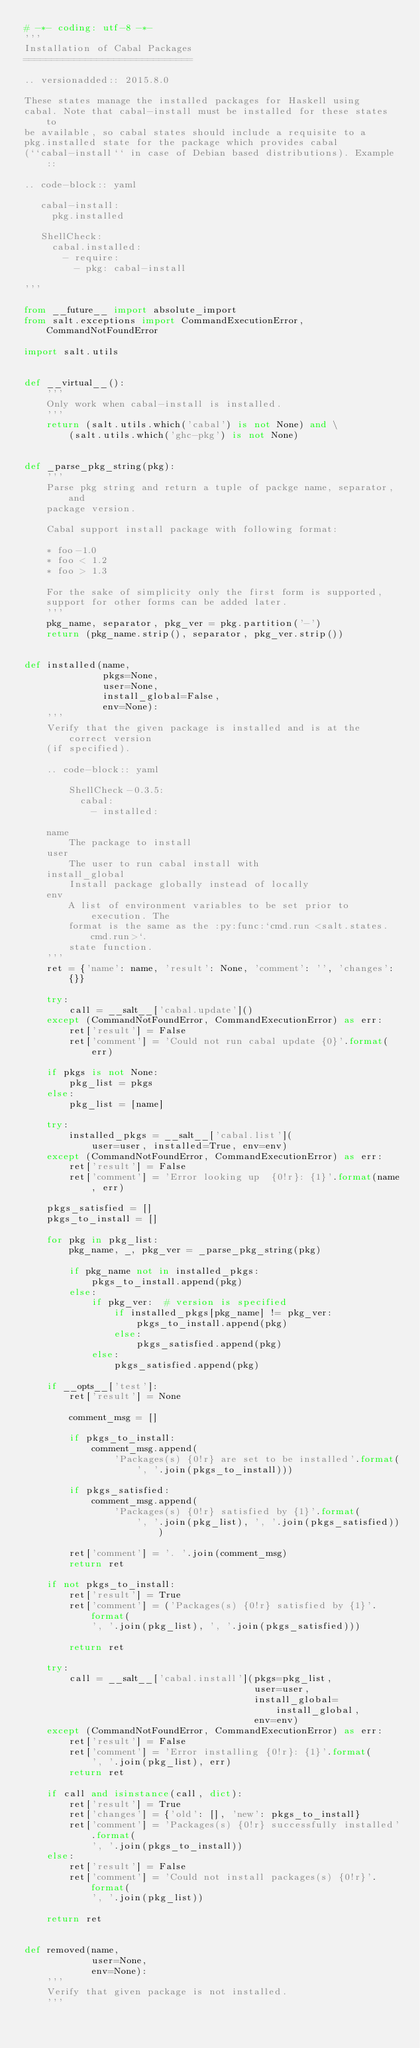Convert code to text. <code><loc_0><loc_0><loc_500><loc_500><_Python_># -*- coding: utf-8 -*-
'''
Installation of Cabal Packages
==============================

.. versionadded:: 2015.8.0

These states manage the installed packages for Haskell using
cabal. Note that cabal-install must be installed for these states to
be available, so cabal states should include a requisite to a
pkg.installed state for the package which provides cabal
(``cabal-install`` in case of Debian based distributions). Example::

.. code-block:: yaml

   cabal-install:
     pkg.installed

   ShellCheck:
     cabal.installed:
       - require:
         - pkg: cabal-install

'''

from __future__ import absolute_import
from salt.exceptions import CommandExecutionError, CommandNotFoundError

import salt.utils


def __virtual__():
    '''
    Only work when cabal-install is installed.
    '''
    return (salt.utils.which('cabal') is not None) and \
        (salt.utils.which('ghc-pkg') is not None)


def _parse_pkg_string(pkg):
    '''
    Parse pkg string and return a tuple of packge name, separator, and
    package version.

    Cabal support install package with following format:

    * foo-1.0
    * foo < 1.2
    * foo > 1.3

    For the sake of simplicity only the first form is supported,
    support for other forms can be added later.
    '''
    pkg_name, separator, pkg_ver = pkg.partition('-')
    return (pkg_name.strip(), separator, pkg_ver.strip())


def installed(name,
              pkgs=None,
              user=None,
              install_global=False,
              env=None):
    '''
    Verify that the given package is installed and is at the correct version
    (if specified).

    .. code-block:: yaml

        ShellCheck-0.3.5:
          cabal:
            - installed:

    name
        The package to install
    user
        The user to run cabal install with
    install_global
        Install package globally instead of locally
    env
        A list of environment variables to be set prior to execution. The
        format is the same as the :py:func:`cmd.run <salt.states.cmd.run>`.
        state function.
    '''
    ret = {'name': name, 'result': None, 'comment': '', 'changes': {}}

    try:
        call = __salt__['cabal.update']()
    except (CommandNotFoundError, CommandExecutionError) as err:
        ret['result'] = False
        ret['comment'] = 'Could not run cabal update {0}'.format(err)

    if pkgs is not None:
        pkg_list = pkgs
    else:
        pkg_list = [name]

    try:
        installed_pkgs = __salt__['cabal.list'](
            user=user, installed=True, env=env)
    except (CommandNotFoundError, CommandExecutionError) as err:
        ret['result'] = False
        ret['comment'] = 'Error looking up  {0!r}: {1}'.format(name, err)

    pkgs_satisfied = []
    pkgs_to_install = []

    for pkg in pkg_list:
        pkg_name, _, pkg_ver = _parse_pkg_string(pkg)

        if pkg_name not in installed_pkgs:
            pkgs_to_install.append(pkg)
        else:
            if pkg_ver:  # version is specified
                if installed_pkgs[pkg_name] != pkg_ver:
                    pkgs_to_install.append(pkg)
                else:
                    pkgs_satisfied.append(pkg)
            else:
                pkgs_satisfied.append(pkg)

    if __opts__['test']:
        ret['result'] = None

        comment_msg = []

        if pkgs_to_install:
            comment_msg.append(
                'Packages(s) {0!r} are set to be installed'.format(
                    ', '.join(pkgs_to_install)))

        if pkgs_satisfied:
            comment_msg.append(
                'Packages(s) {0!r} satisfied by {1}'.format(
                    ', '.join(pkg_list), ', '.join(pkgs_satisfied)))

        ret['comment'] = '. '.join(comment_msg)
        return ret

    if not pkgs_to_install:
        ret['result'] = True
        ret['comment'] = ('Packages(s) {0!r} satisfied by {1}'.format(
            ', '.join(pkg_list), ', '.join(pkgs_satisfied)))

        return ret

    try:
        call = __salt__['cabal.install'](pkgs=pkg_list,
                                         user=user,
                                         install_global=install_global,
                                         env=env)
    except (CommandNotFoundError, CommandExecutionError) as err:
        ret['result'] = False
        ret['comment'] = 'Error installing {0!r}: {1}'.format(
            ', '.join(pkg_list), err)
        return ret

    if call and isinstance(call, dict):
        ret['result'] = True
        ret['changes'] = {'old': [], 'new': pkgs_to_install}
        ret['comment'] = 'Packages(s) {0!r} successfully installed'.format(
            ', '.join(pkgs_to_install))
    else:
        ret['result'] = False
        ret['comment'] = 'Could not install packages(s) {0!r}'.format(
            ', '.join(pkg_list))

    return ret


def removed(name,
            user=None,
            env=None):
    '''
    Verify that given package is not installed.
    '''
</code> 